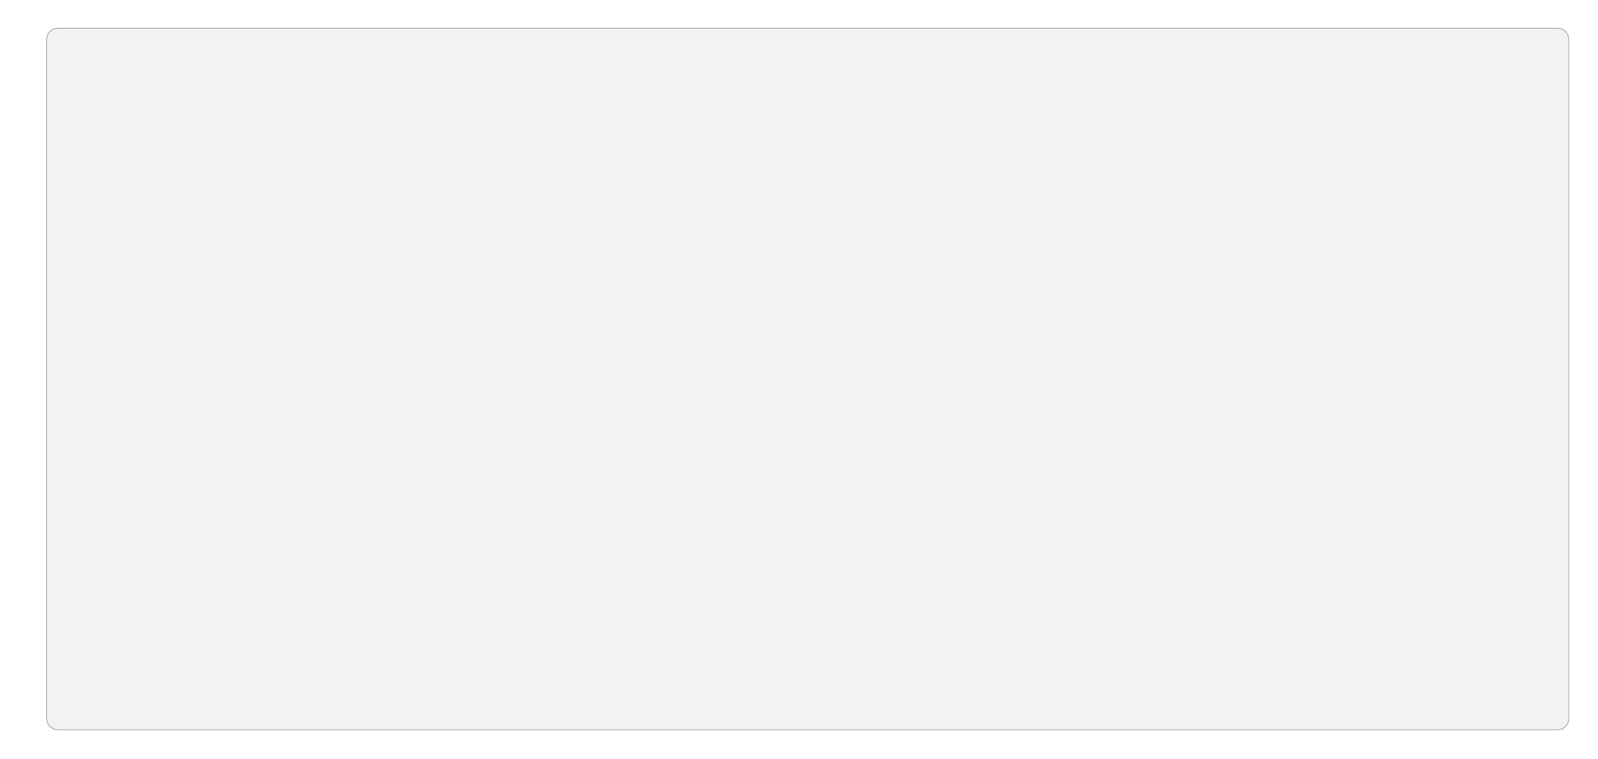What is the first node in the flow chart? The first node in the flow chart represents the beginning of the workflow, identified as "Start of Shift."
Answer: Start of Shift How many nodes are in the diagram? By counting each distinct step in the flow, we find there are five nodes outlining the process from start to end.
Answer: 5 What is the relationship between “Assess Daily Tasks” and “Allocate Time Blocks”? There is a direct pathway from "Assess Daily Tasks" to "Allocate Time Blocks" indicating that after assessing tasks, the next step is to allocate time.
Answer: Direct pathway What action is performed after "Take Breaks"? Following "Take Breaks," the next action in the flow chart is "End of Shift Review," indicating a transition from breaks to reviewing tasks.
Answer: End of Shift Review Which node focuses on scheduling? The node explicitly concerned with organizing time within the workday is "Allocate Time Blocks," as it emphasizes dividing the day into scheduled segments.
Answer: Allocate Time Blocks Why are breaks incorporated in the workflow? Breaks are included to help maintain focus and prevent burnout, serving as necessary pauses in the work process, which supports overall productivity.
Answer: Maintain focus What does the "End of Shift Review" node emphasize? This node emphasizes reflection on completed tasks and planning for the next workday, making it a pivotal part of daily productivity assessment.
Answer: Review and plan Which node follows "Assess Daily Tasks" in the workflow? The logical next step, following "Assess Daily Tasks," is "Allocate Time Blocks," illustrating a clear sequence in task management.
Answer: Allocate Time Blocks How does the flow chart help with time management? The flow chart visually outlines essential steps for effective daily task management, guiding how to prioritize and allocate time throughout the workday.
Answer: Time management guidance 